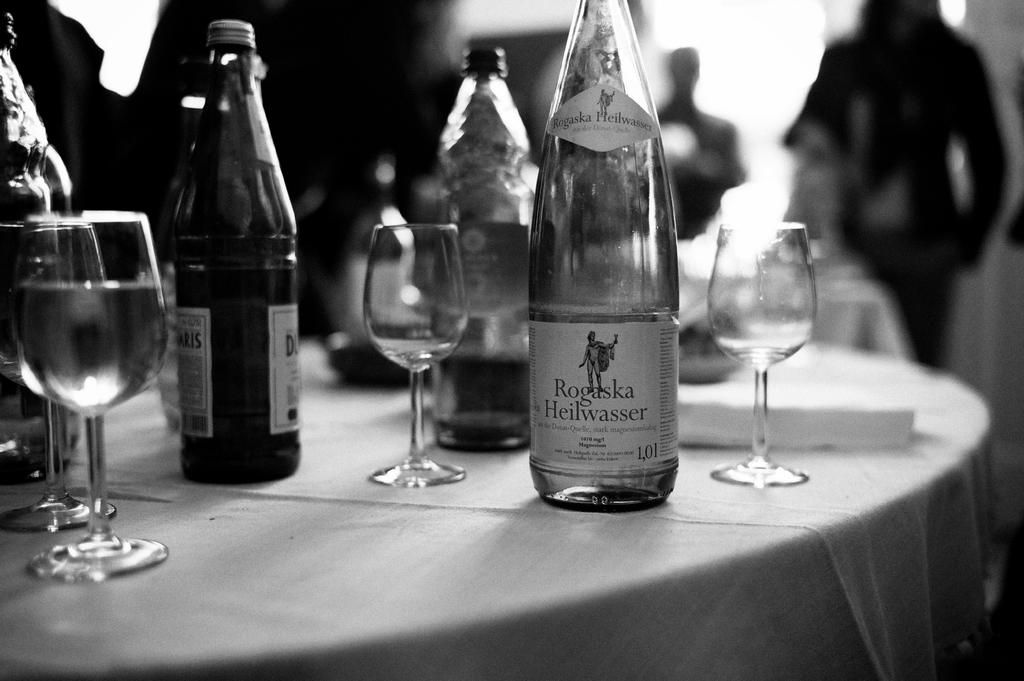What is located in the bottom left side of the image? There is a table in the bottom left side of the image. What is covering the table? There is a cloth on the table. What objects are on the table? There are glasses and bottles on the table. Where is the person in the image? There is a person standing in the top right side of the image. What type of day is depicted in the image? The provided facts do not mention any specific day or weather conditions, so it cannot be determined from the image. Can you describe the person's facial expression in the image? The provided facts do not mention the person's facial expression, so it cannot be determined from the image. 